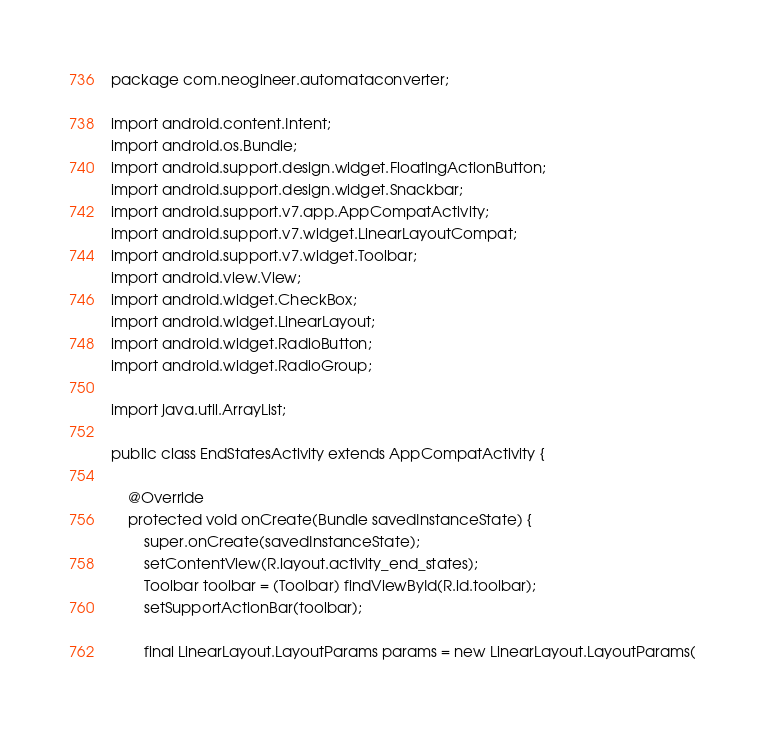<code> <loc_0><loc_0><loc_500><loc_500><_Java_>package com.neogineer.automataconverter;

import android.content.Intent;
import android.os.Bundle;
import android.support.design.widget.FloatingActionButton;
import android.support.design.widget.Snackbar;
import android.support.v7.app.AppCompatActivity;
import android.support.v7.widget.LinearLayoutCompat;
import android.support.v7.widget.Toolbar;
import android.view.View;
import android.widget.CheckBox;
import android.widget.LinearLayout;
import android.widget.RadioButton;
import android.widget.RadioGroup;

import java.util.ArrayList;

public class EndStatesActivity extends AppCompatActivity {

    @Override
    protected void onCreate(Bundle savedInstanceState) {
        super.onCreate(savedInstanceState);
        setContentView(R.layout.activity_end_states);
        Toolbar toolbar = (Toolbar) findViewById(R.id.toolbar);
        setSupportActionBar(toolbar);

        final LinearLayout.LayoutParams params = new LinearLayout.LayoutParams(</code> 